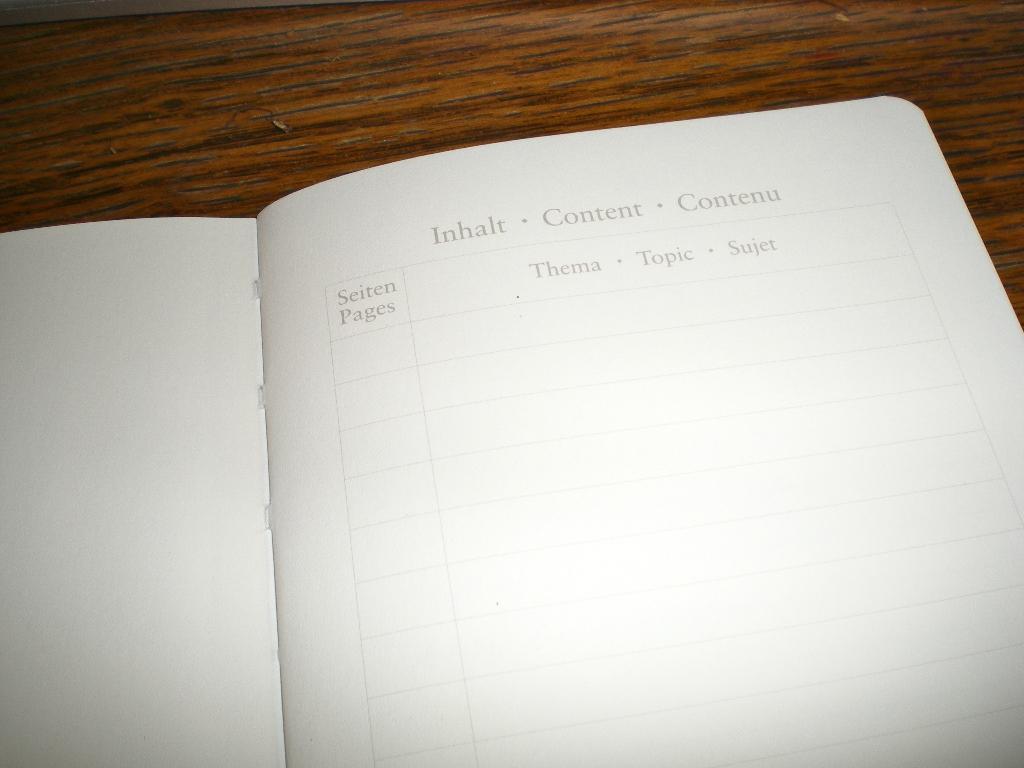What is the left column/?
Offer a very short reply. Seiten pages. 